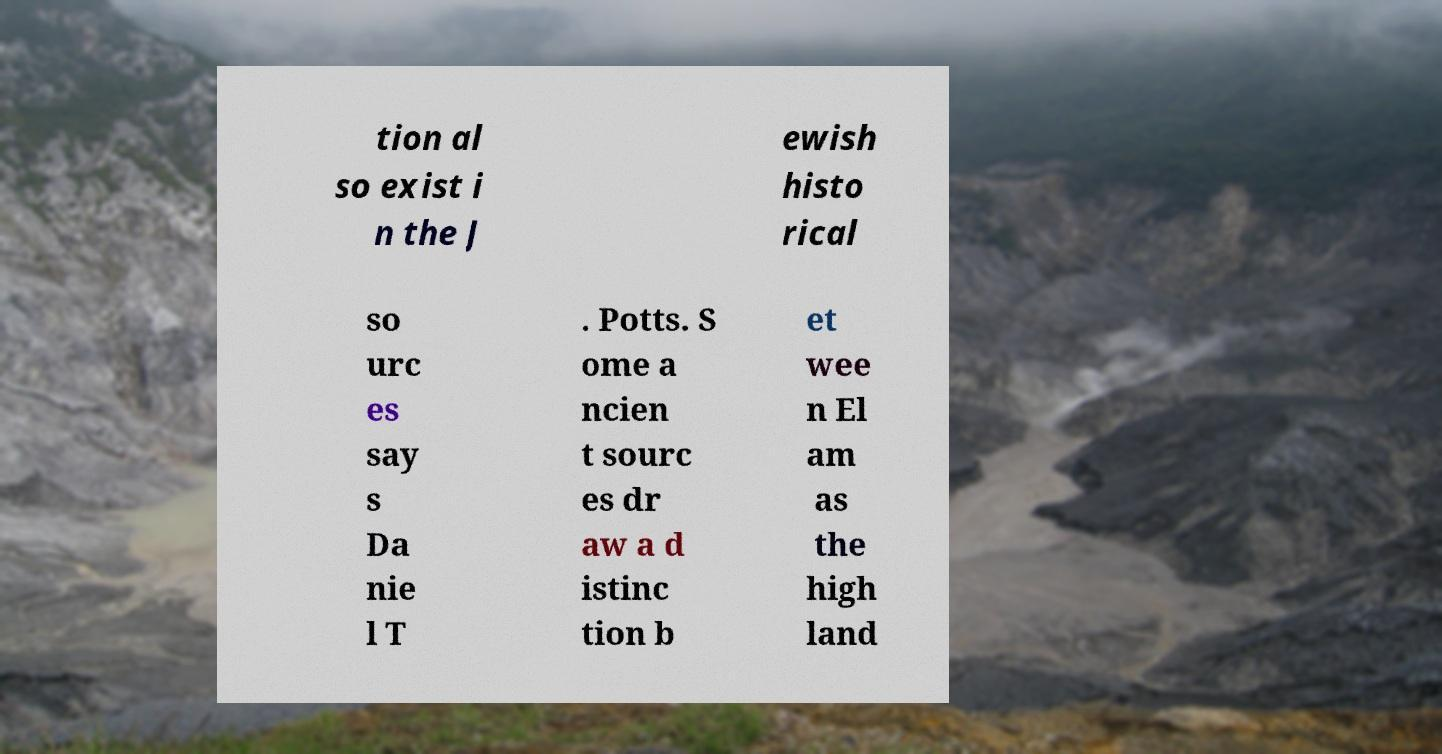For documentation purposes, I need the text within this image transcribed. Could you provide that? tion al so exist i n the J ewish histo rical so urc es say s Da nie l T . Potts. S ome a ncien t sourc es dr aw a d istinc tion b et wee n El am as the high land 